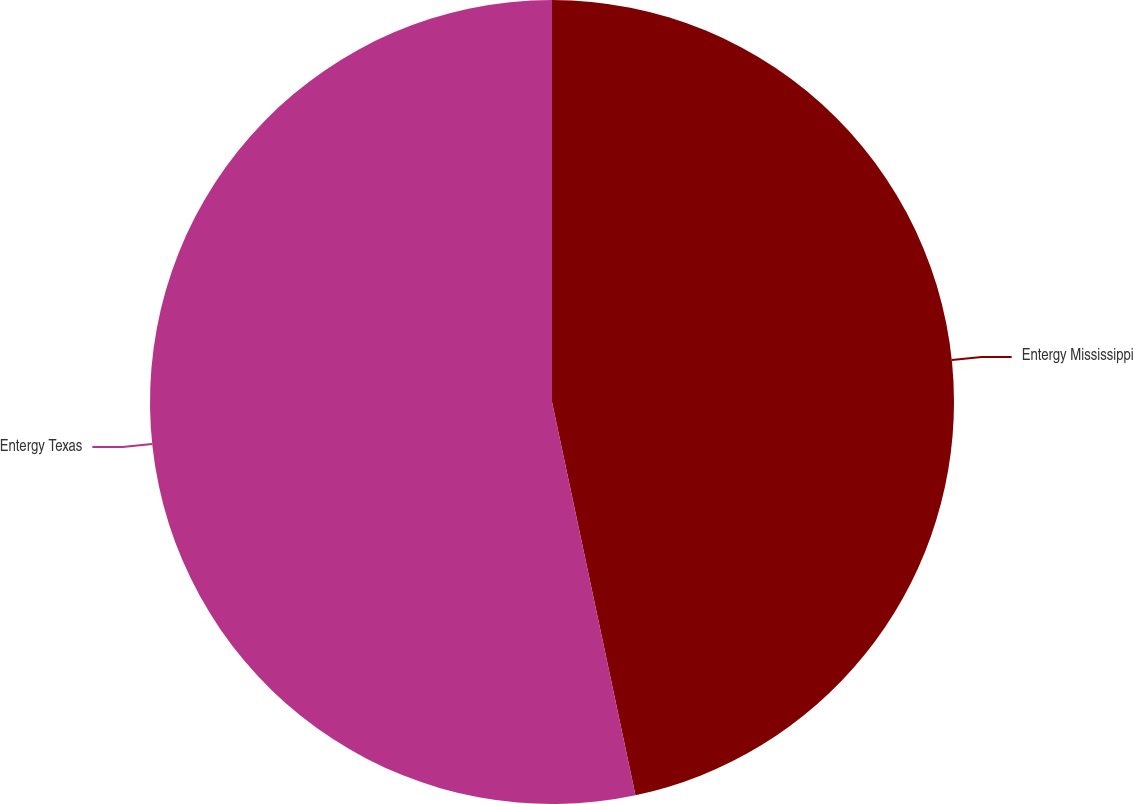Convert chart to OTSL. <chart><loc_0><loc_0><loc_500><loc_500><pie_chart><fcel>Entergy Mississippi<fcel>Entergy Texas<nl><fcel>46.67%<fcel>53.33%<nl></chart> 